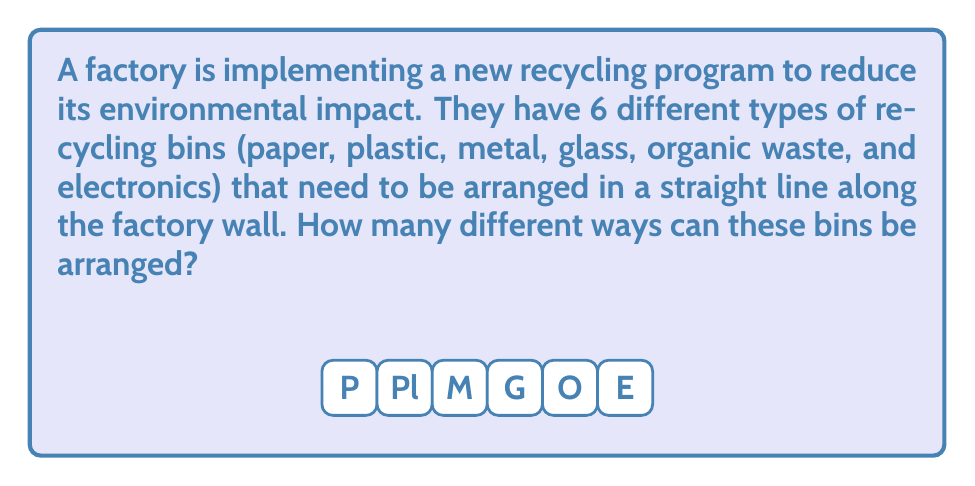Could you help me with this problem? Let's approach this step-by-step:

1) This is a permutation problem. We need to arrange 6 distinct objects (the different types of recycling bins) in a line.

2) In permutation problems, the number of ways to arrange n distinct objects is given by the factorial of n, denoted as n!.

3) In this case, n = 6 (for the 6 types of recycling bins).

4) Therefore, the number of possible arrangements is 6!.

5) Let's calculate 6!:
   
   $$6! = 6 \times 5 \times 4 \times 3 \times 2 \times 1 = 720$$

6) This means there are 720 different ways to arrange the recycling bins.

Interpretation: This large number of possibilities highlights the importance of careful planning in the factory's recycling program. The retired worker might reflect on how such attention to detail in environmental practices could have made a difference during their time at the factory.
Answer: 720 